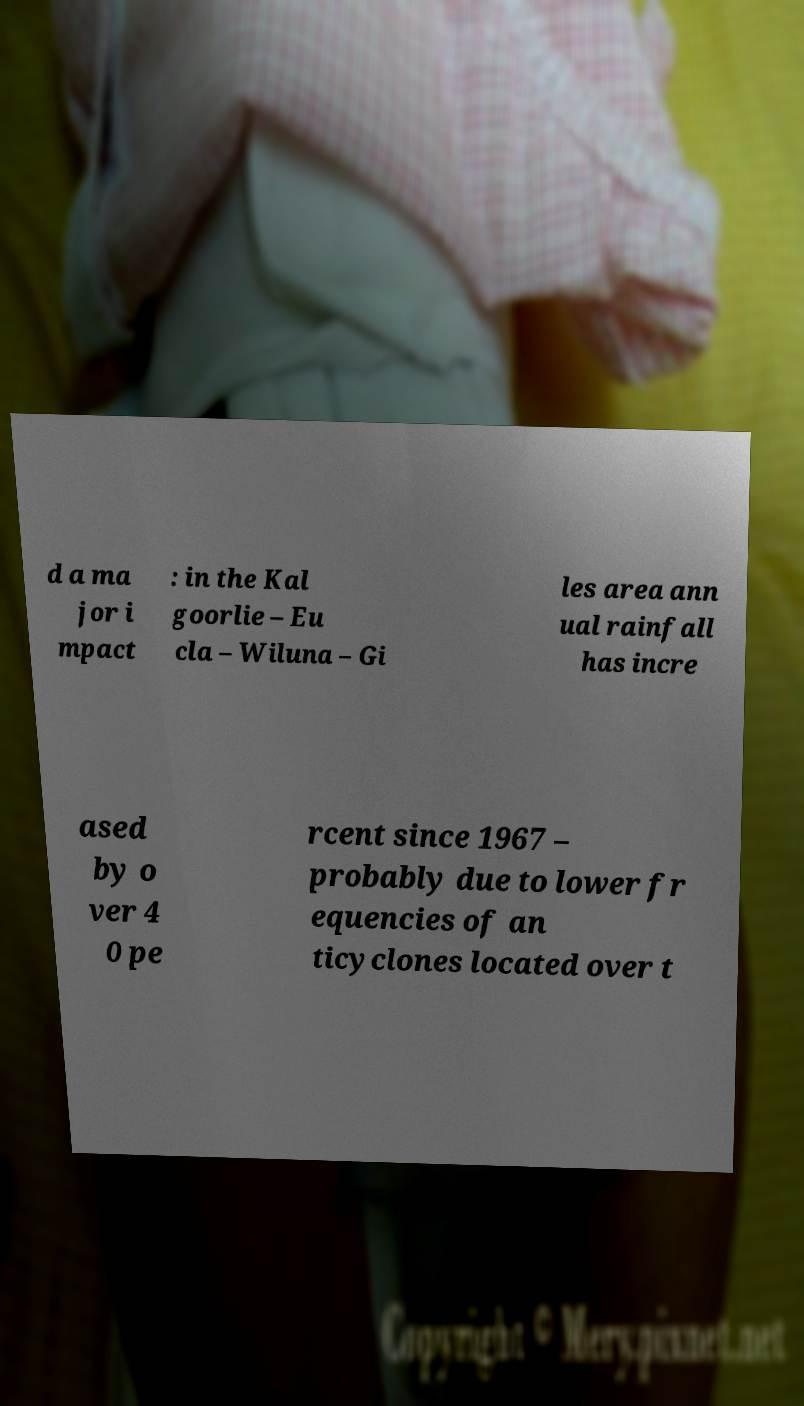I need the written content from this picture converted into text. Can you do that? d a ma jor i mpact : in the Kal goorlie – Eu cla – Wiluna – Gi les area ann ual rainfall has incre ased by o ver 4 0 pe rcent since 1967 – probably due to lower fr equencies of an ticyclones located over t 